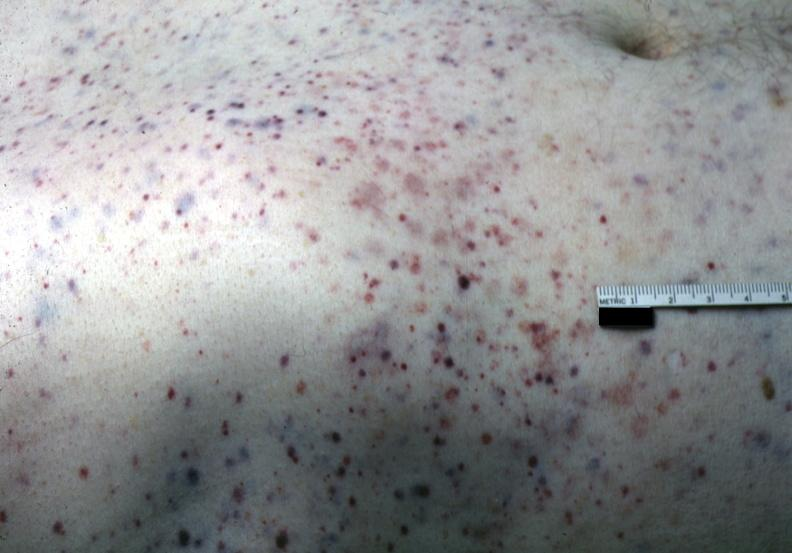s petechial and purpuric hemorrhages present?
Answer the question using a single word or phrase. Yes 